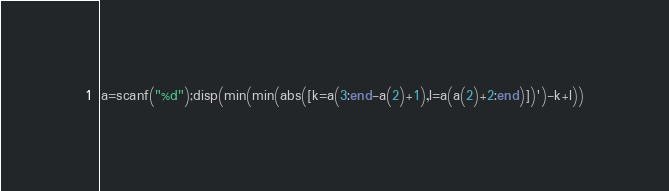Convert code to text. <code><loc_0><loc_0><loc_500><loc_500><_Octave_>a=scanf("%d");disp(min(min(abs([k=a(3:end-a(2)+1),l=a(a(2)+2:end)])')-k+l))</code> 